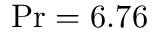Convert formula to latex. <formula><loc_0><loc_0><loc_500><loc_500>P r = 6 . 7 6</formula> 